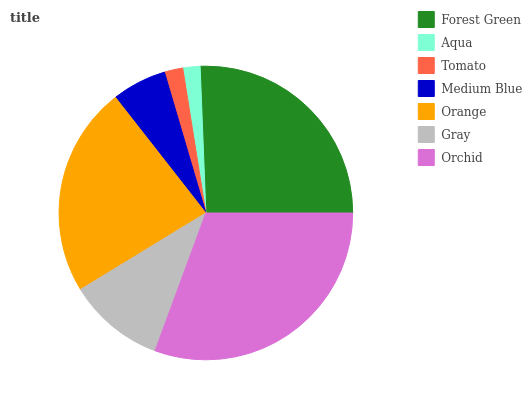Is Aqua the minimum?
Answer yes or no. Yes. Is Orchid the maximum?
Answer yes or no. Yes. Is Tomato the minimum?
Answer yes or no. No. Is Tomato the maximum?
Answer yes or no. No. Is Tomato greater than Aqua?
Answer yes or no. Yes. Is Aqua less than Tomato?
Answer yes or no. Yes. Is Aqua greater than Tomato?
Answer yes or no. No. Is Tomato less than Aqua?
Answer yes or no. No. Is Gray the high median?
Answer yes or no. Yes. Is Gray the low median?
Answer yes or no. Yes. Is Tomato the high median?
Answer yes or no. No. Is Aqua the low median?
Answer yes or no. No. 